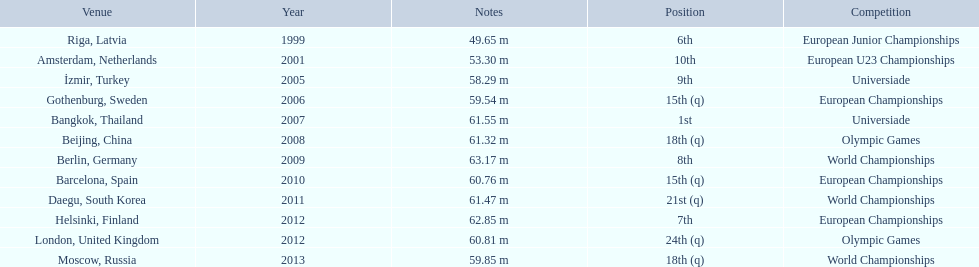What were the distances of mayer's throws? 49.65 m, 53.30 m, 58.29 m, 59.54 m, 61.55 m, 61.32 m, 63.17 m, 60.76 m, 61.47 m, 62.85 m, 60.81 m, 59.85 m. Which of these went the farthest? 63.17 m. 